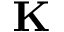Convert formula to latex. <formula><loc_0><loc_0><loc_500><loc_500>K</formula> 